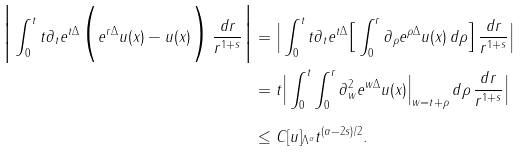Convert formula to latex. <formula><loc_0><loc_0><loc_500><loc_500>\Big | \int _ { 0 } ^ { t } t \partial _ { t } e ^ { t \Delta } \Big ( e ^ { r \Delta } u ( x ) - u ( x ) \Big ) \, \frac { d r } { r ^ { 1 + s } } \Big | & = \Big | \int _ { 0 } ^ { t } t \partial _ { t } e ^ { t \Delta } \Big [ \int _ { 0 } ^ { r } \partial _ { \rho } e ^ { \rho \Delta } u ( x ) \, d \rho \Big ] \, \frac { d r } { r ^ { 1 + s } } \Big | \\ & = t \Big | \int _ { 0 } ^ { t } \int _ { 0 } ^ { r } \partial _ { w } ^ { 2 } e ^ { w \Delta } u ( x ) \Big | _ { w = t + \rho } \, d \rho \, \frac { d r } { r ^ { 1 + s } } \Big | \\ & \leq C [ u ] _ { \Lambda ^ { \alpha } } t ^ { ( \alpha - 2 s ) / 2 } .</formula> 